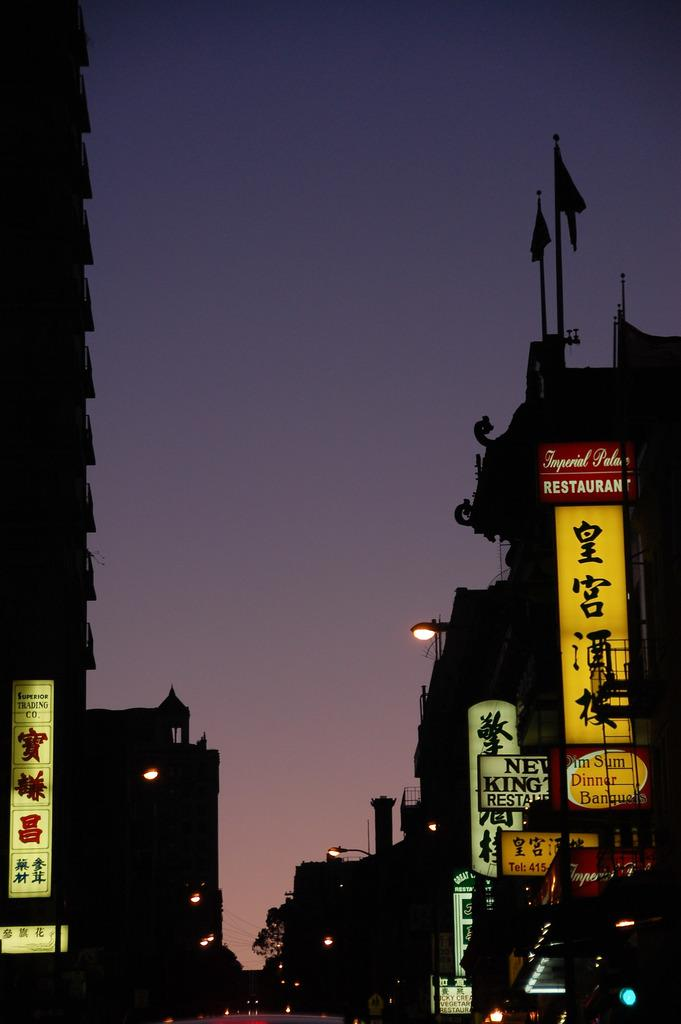<image>
Render a clear and concise summary of the photo. A dark city street has a red Imperial Place Restaurant sign attached to a building. 